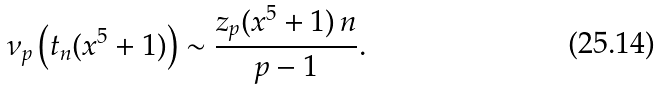<formula> <loc_0><loc_0><loc_500><loc_500>\nu _ { p } \left ( t _ { n } ( x ^ { 5 } + 1 ) \right ) \sim \frac { z _ { p } ( x ^ { 5 } + 1 ) \, n } { p - 1 } .</formula> 